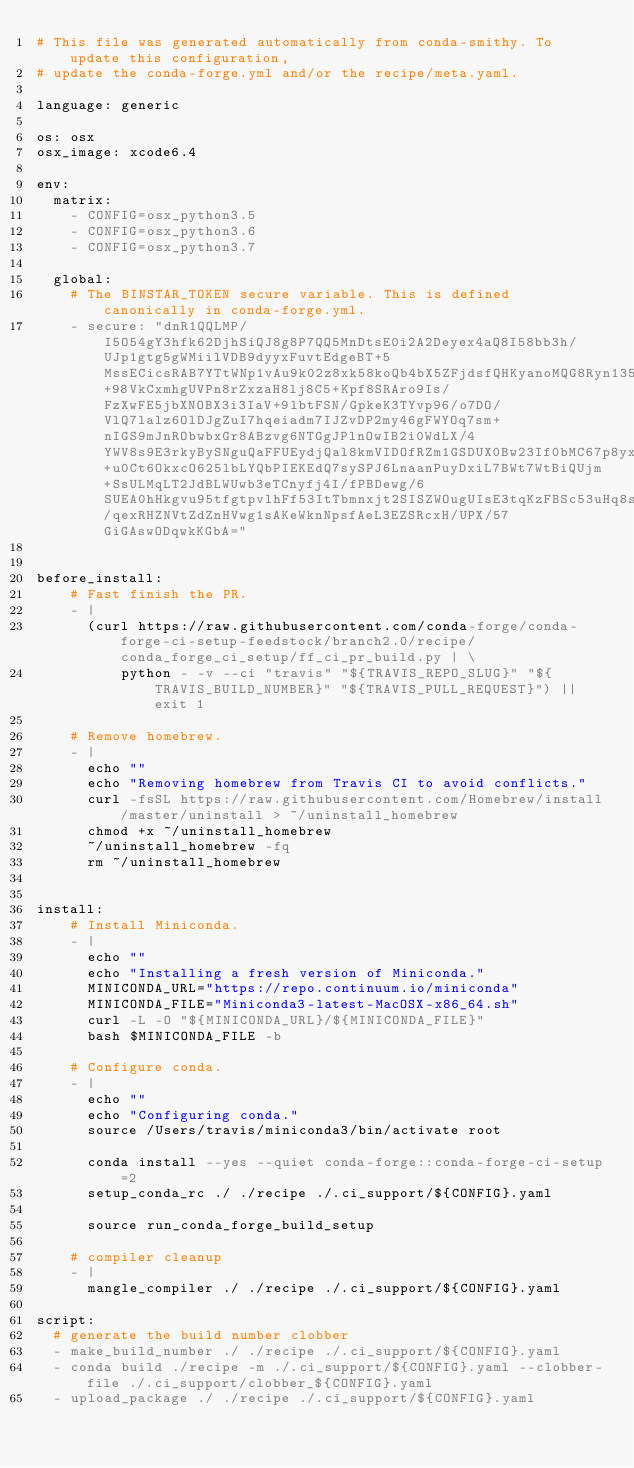Convert code to text. <code><loc_0><loc_0><loc_500><loc_500><_YAML_># This file was generated automatically from conda-smithy. To update this configuration,
# update the conda-forge.yml and/or the recipe/meta.yaml.

language: generic

os: osx
osx_image: xcode6.4

env:
  matrix:
    - CONFIG=osx_python3.5
    - CONFIG=osx_python3.6
    - CONFIG=osx_python3.7

  global:
    # The BINSTAR_TOKEN secure variable. This is defined canonically in conda-forge.yml.
    - secure: "dnR1QQLMP/I5O54gY3hfk62DjhSiQJ8g8P7QQ5MnDtsE0i2A2Deyex4aQ8I58bb3h/UJp1gtg5gWMiilVDB9dyyxFuvtEdgeBT+5MssECicsRAB7YTtWNp1vAu9k02z8xk58koQb4bX5ZFjdsfQHKyanoMQG8Ryn135iTRdhXJ18hcGQh3WarMOEiod2AgI2ZrNa+98VkCxmhgUVPn8rZxzaH8lj8C5+Kpf8SRAro9Is/FzXwFE5jbXNOBX3i3IaV+9lbtFSN/GpkeK3TYvp96/o7DO/VlQ7lalz6OlDJgZuI7hqeiadm7IJZvDP2my46gFWYOq7sm+nIGS9mJnRObwbxGr8ABzvg6NTGgJPlnOwIB2i0WdLX/4YWV8s9E3rkyBySNguQaFFUEydjQal8kmVIDOfRZm1GSDUX0Bw23If0bMC67p8yxUjNa+u0Ct6OkxcO625lbLYQbPIEKEdQ7sySPJ6LnaanPuyDxiL7BWt7WtBiQUjm+SsULMqLT2JdBLWUwb3eTCnyfj4I/fPBDewg/6SUEA0hHkgvu95tfgtpvlhFf53ItTbmnxjt2SISZWOugUIsE3tqKzFBSc53uHq8sCeQUSqYkzVTnfRA6vh/qexRHZNVtZdZnHVwg1sAKeWknNpsfAeL3EZSRcxH/UPX/57GiGAswODqwkKGbA="


before_install:
    # Fast finish the PR.
    - |
      (curl https://raw.githubusercontent.com/conda-forge/conda-forge-ci-setup-feedstock/branch2.0/recipe/conda_forge_ci_setup/ff_ci_pr_build.py | \
          python - -v --ci "travis" "${TRAVIS_REPO_SLUG}" "${TRAVIS_BUILD_NUMBER}" "${TRAVIS_PULL_REQUEST}") || exit 1

    # Remove homebrew.
    - |
      echo ""
      echo "Removing homebrew from Travis CI to avoid conflicts."
      curl -fsSL https://raw.githubusercontent.com/Homebrew/install/master/uninstall > ~/uninstall_homebrew
      chmod +x ~/uninstall_homebrew
      ~/uninstall_homebrew -fq
      rm ~/uninstall_homebrew


install:
    # Install Miniconda.
    - |
      echo ""
      echo "Installing a fresh version of Miniconda."
      MINICONDA_URL="https://repo.continuum.io/miniconda"
      MINICONDA_FILE="Miniconda3-latest-MacOSX-x86_64.sh"
      curl -L -O "${MINICONDA_URL}/${MINICONDA_FILE}"
      bash $MINICONDA_FILE -b

    # Configure conda.
    - |
      echo ""
      echo "Configuring conda."
      source /Users/travis/miniconda3/bin/activate root

      conda install --yes --quiet conda-forge::conda-forge-ci-setup=2
      setup_conda_rc ./ ./recipe ./.ci_support/${CONFIG}.yaml

      source run_conda_forge_build_setup

    # compiler cleanup
    - |
      mangle_compiler ./ ./recipe ./.ci_support/${CONFIG}.yaml

script:
  # generate the build number clobber
  - make_build_number ./ ./recipe ./.ci_support/${CONFIG}.yaml
  - conda build ./recipe -m ./.ci_support/${CONFIG}.yaml --clobber-file ./.ci_support/clobber_${CONFIG}.yaml
  - upload_package ./ ./recipe ./.ci_support/${CONFIG}.yaml
</code> 